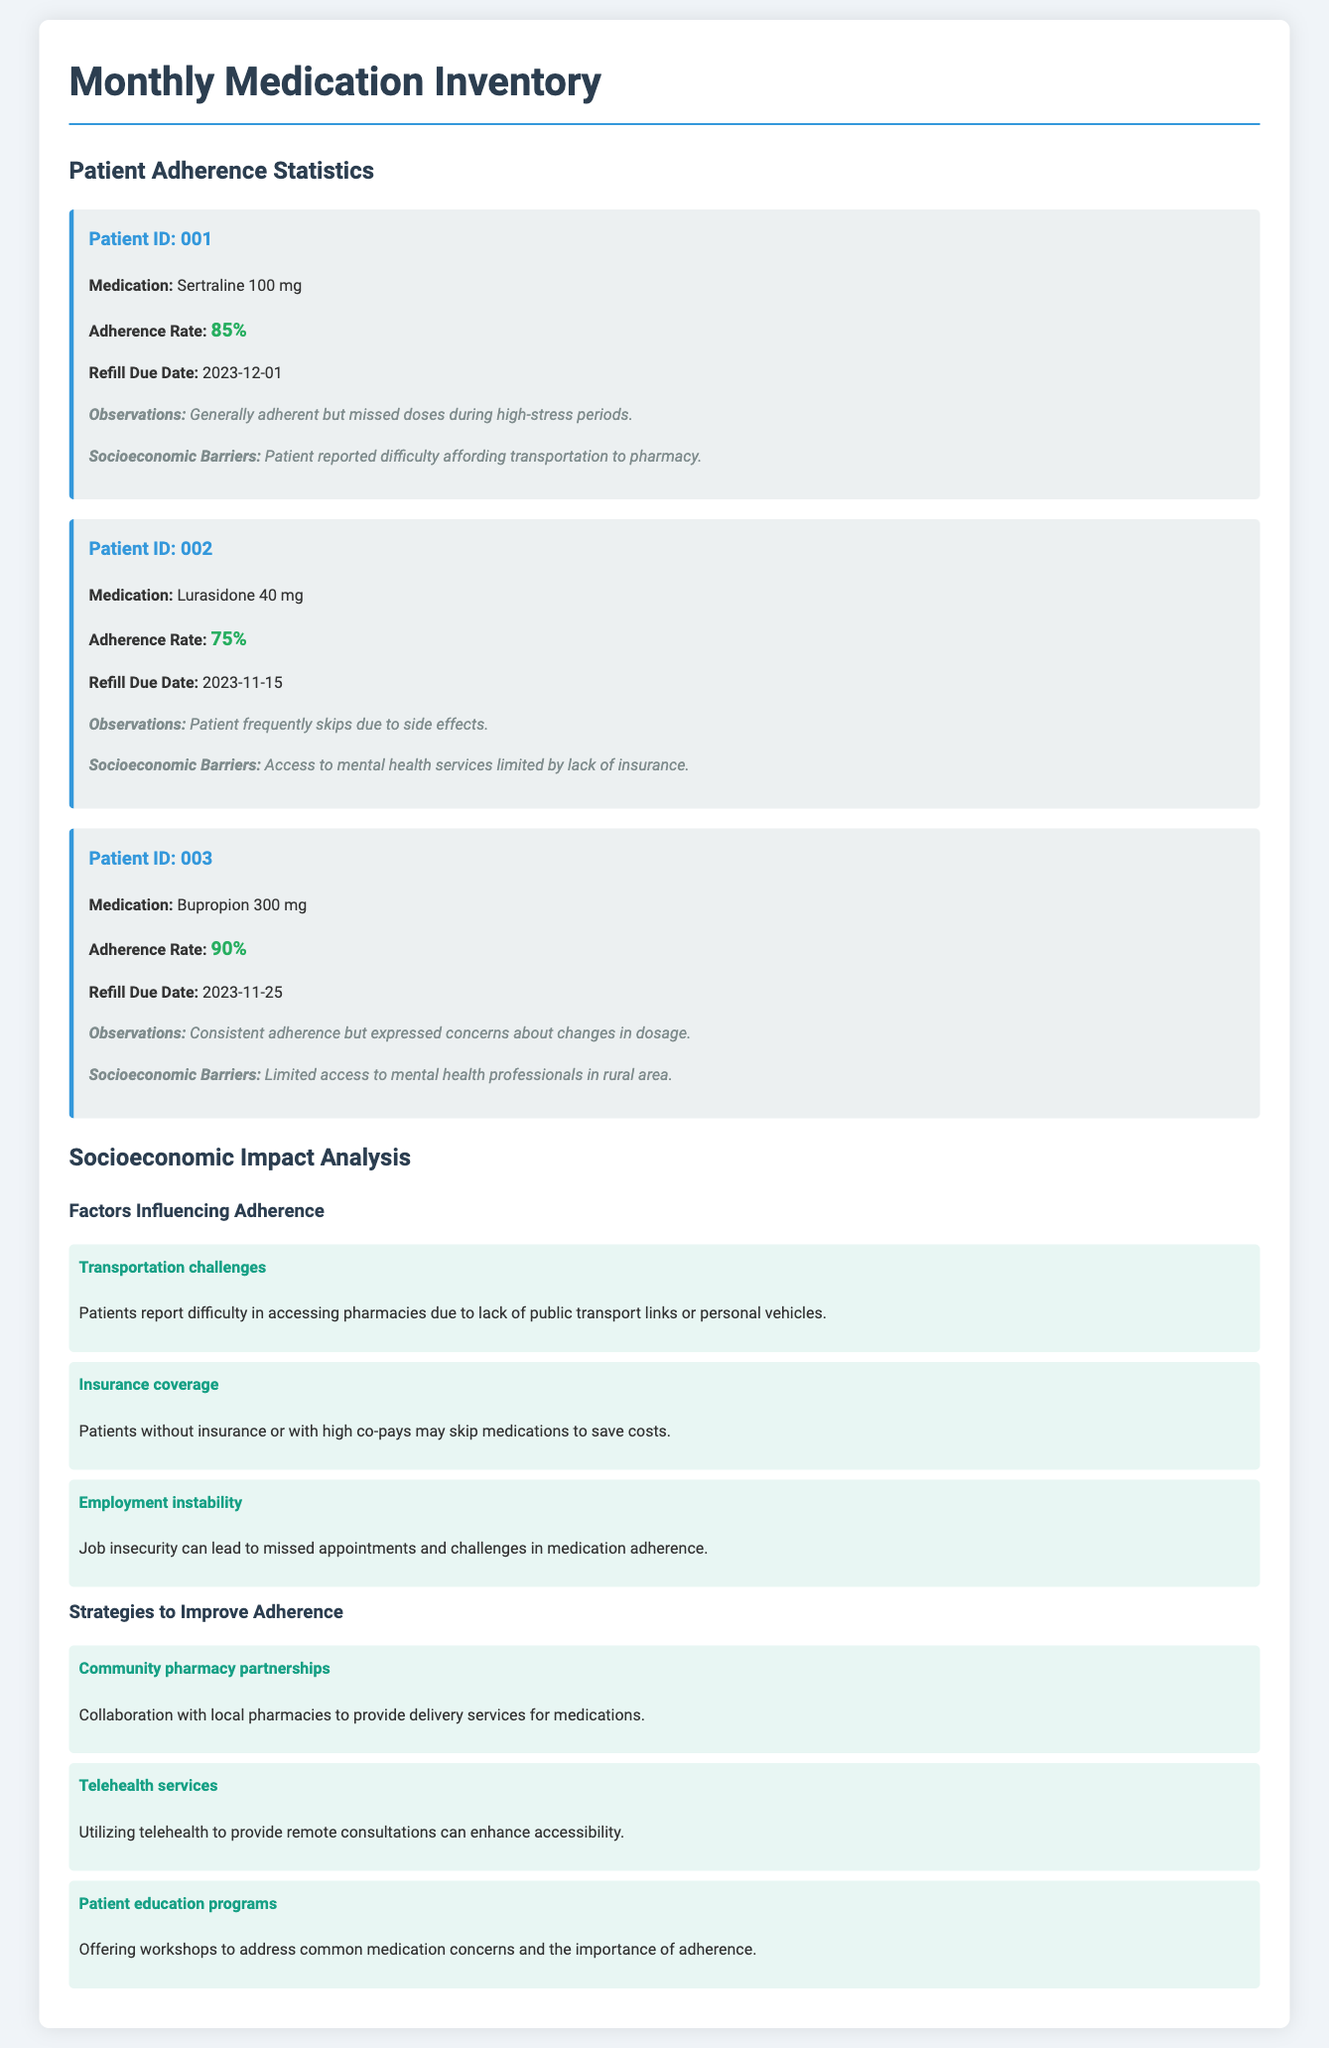what is the medication for Patient ID 001? The document lists the specific medication for each patient, and for Patient ID 001, it is Sertraline 100 mg.
Answer: Sertraline 100 mg what is the adherence rate of Patient ID 002? The adherence rate for each patient is specified, and for Patient ID 002, it is 75%.
Answer: 75% when is the refill due date for Patient ID 003? The refill due date is provided for each patient, and for Patient ID 003, it is 2023-11-25.
Answer: 2023-11-25 what socioeconomic barrier is reported by Patient ID 001? Each patient's notes include their reported socioeconomic barriers, and for Patient ID 001, it is affording transportation to pharmacy.
Answer: Affording transportation to pharmacy which factor is related to missed appointments? The document outlines factors influencing adherence, one of which is job insecurity affecting missed appointments.
Answer: Employment instability what percentage of adherence does the most adherent patient have? The adherence rates are provided, and the most adherent patient, Patient ID 003, has an adherence rate of 90%.
Answer: 90% what strategy is suggested to improve medication adherence? The document presents various strategies, one of which is community pharmacy partnerships to help improve adherence.
Answer: Community pharmacy partnerships how many patients had difficulties due to side effects? According to the notes, one patient, Patient ID 002, skips doses due to side effects.
Answer: 1 patient which medication is prescribed to Patient ID 002? The document specifies the medication prescribed to each patient, and for Patient ID 002, it is Lurasidone 40 mg.
Answer: Lurasidone 40 mg 